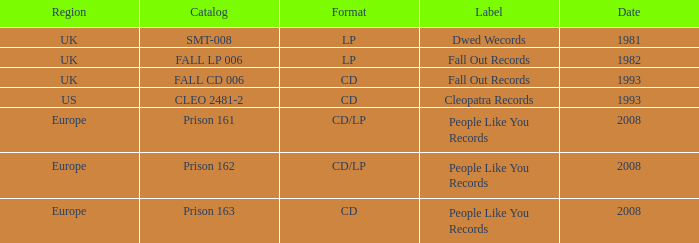Which Format has a Date of 1993, and a Catalog of cleo 2481-2? CD. 